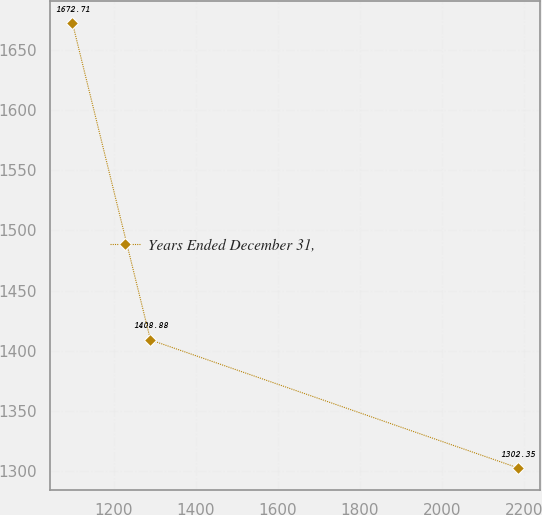Convert chart. <chart><loc_0><loc_0><loc_500><loc_500><line_chart><ecel><fcel>Years Ended December 31,<nl><fcel>1098.65<fcel>1672.71<nl><fcel>1288.92<fcel>1408.88<nl><fcel>2185.1<fcel>1302.35<nl></chart> 